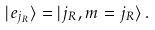<formula> <loc_0><loc_0><loc_500><loc_500>| e _ { j _ { R } } \rangle = | { j _ { R } } , m = { j _ { R } } \rangle \, .</formula> 